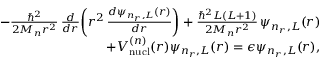Convert formula to latex. <formula><loc_0><loc_0><loc_500><loc_500>\begin{array} { r l r } & { - \frac { \hbar { ^ } { 2 } } { 2 M _ { n } r ^ { 2 } } \, \frac { d } { d r } \left ( r ^ { 2 } \, \frac { d \psi _ { n _ { r } , L } ( r ) } { d r } \right ) + \frac { \hbar { ^ } { 2 } L ( L + 1 ) } { 2 M _ { n } r ^ { 2 } } \, \psi _ { n _ { r } , L } ( r ) } \\ & { \, + V _ { n u c l } ^ { ( n ) } ( r ) \psi _ { n _ { r } , L } ( r ) = \epsilon \psi _ { n _ { r } , L } ( r ) , } \end{array}</formula> 